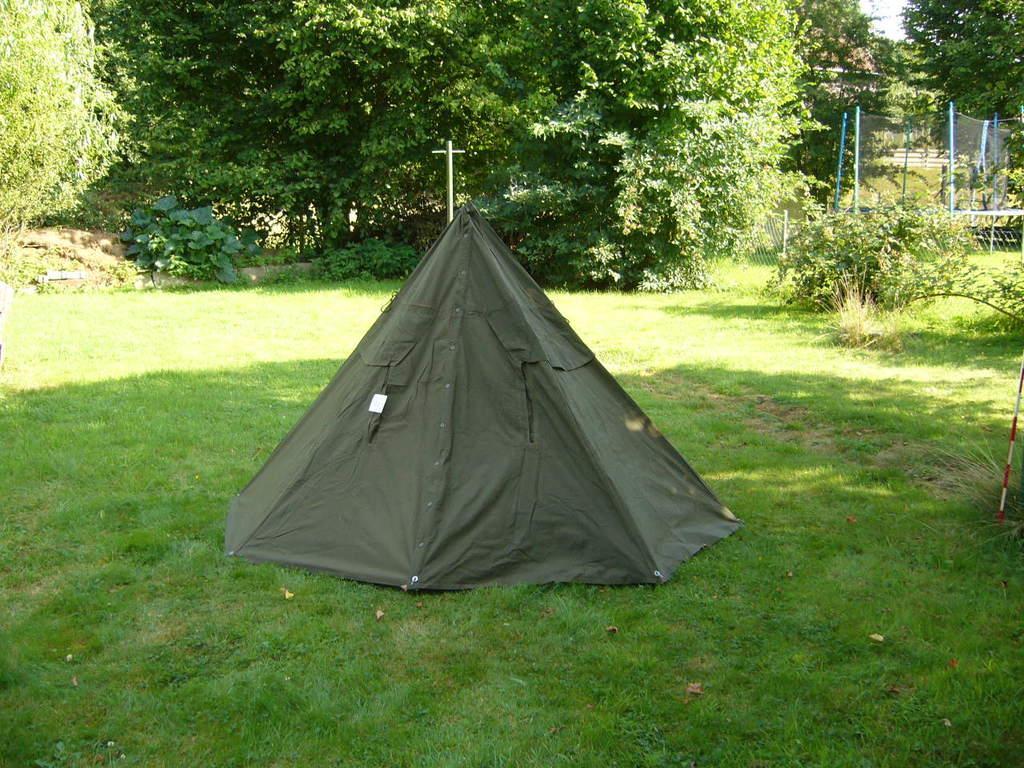How would you summarize this image in a sentence or two? At the center of the image there is a camp. In the background there are some trees and sky. 